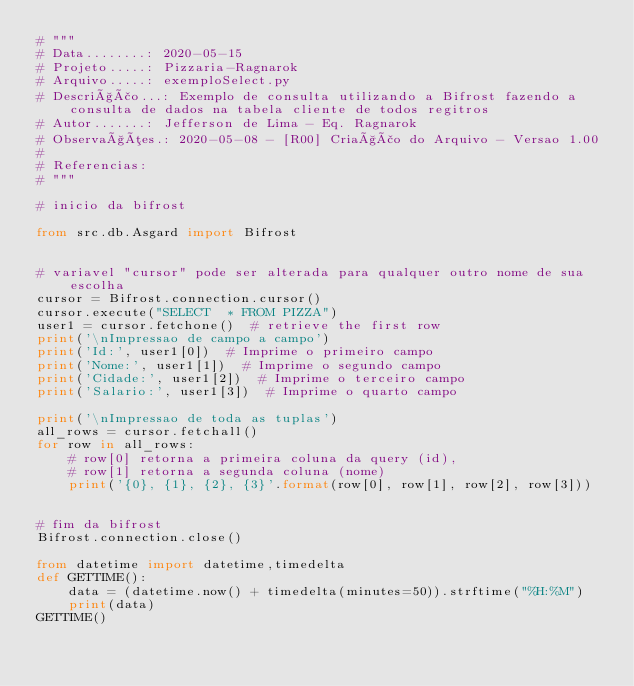<code> <loc_0><loc_0><loc_500><loc_500><_Python_># """
# Data........: 2020-05-15
# Projeto.....: Pizzaria-Ragnarok
# Arquivo.....: exemploSelect.py
# Descrição...: Exemplo de consulta utilizando a Bifrost fazendo a consulta de dados na tabela cliente de todos regitros
# Autor.......: Jefferson de Lima - Eq. Ragnarok
# Observações.: 2020-05-08 - [R00] Criação do Arquivo - Versao 1.00
#
# Referencias:
# """

# inicio da bifrost

from src.db.Asgard import Bifrost


# variavel "cursor" pode ser alterada para qualquer outro nome de sua escolha
cursor = Bifrost.connection.cursor()
cursor.execute("SELECT  * FROM PIZZA")
user1 = cursor.fetchone()  # retrieve the first row
print('\nImpressao de campo a campo')
print('Id:', user1[0])  # Imprime o primeiro campo
print('Nome:', user1[1])  # Imprime o segundo campo
print('Cidade:', user1[2])  # Imprime o terceiro campo
print('Salario:', user1[3])  # Imprime o quarto campo

print('\nImpressao de toda as tuplas')
all_rows = cursor.fetchall()
for row in all_rows:
    # row[0] retorna a primeira coluna da query (id),
    # row[1] retorna a segunda coluna (nome)
    print('{0}, {1}, {2}, {3}'.format(row[0], row[1], row[2], row[3]))


# fim da bifrost
Bifrost.connection.close()

from datetime import datetime,timedelta
def GETTIME():
    data = (datetime.now() + timedelta(minutes=50)).strftime("%H:%M")
    print(data)
GETTIME()</code> 